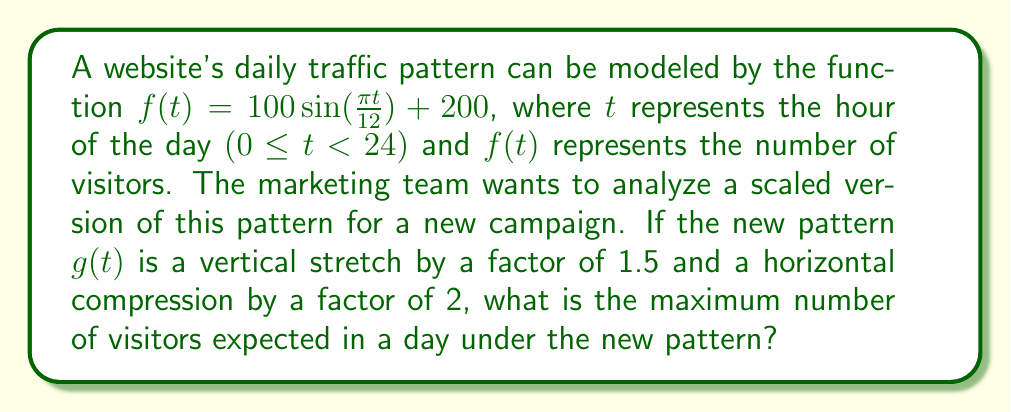Provide a solution to this math problem. To solve this problem, we need to follow these steps:

1. Identify the transformations applied to $f(t)$ to get $g(t)$:
   - Vertical stretch by a factor of 1.5
   - Horizontal compression by a factor of 2

2. Apply these transformations to $f(t)$ to get $g(t)$:
   $g(t) = 1.5f(2t)$
   $g(t) = 1.5[100 \sin(\frac{\pi (2t)}{12}) + 200]$
   $g(t) = 150 \sin(\frac{\pi t}{6}) + 300$

3. To find the maximum number of visitors, we need to find the maximum value of $g(t)$:
   - The sine function has a maximum value of 1 when its argument is $\frac{\pi}{2} + 2\pi n$, where $n$ is an integer.
   - In this case, $\frac{\pi t}{6} = \frac{\pi}{2}$ when $t = 3$

4. Calculate the maximum value:
   $g(3) = 150 \sin(\frac{\pi}{2}) + 300$
   $g(3) = 150(1) + 300 = 450$

Therefore, the maximum number of visitors expected in a day under the new pattern is 450.
Answer: 450 visitors 